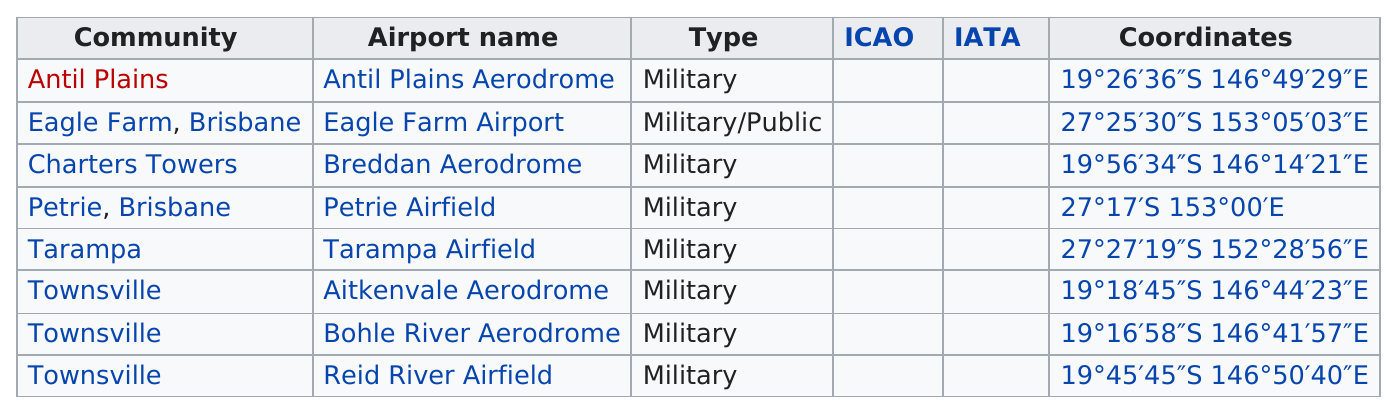Specify some key components in this picture. Townsville is home to the community with the most airports, making it a prime location for aviation enthusiasts and travelers. Eagle Farm Airport in Brisbane, Queensland is the only public airport in the community that has it. According to the list, there are 5 communities other than Townsville. There are three airports in Townsville. There are no other airports in Australia that are of the "military/public" type besides Eagle Farm Airport. 